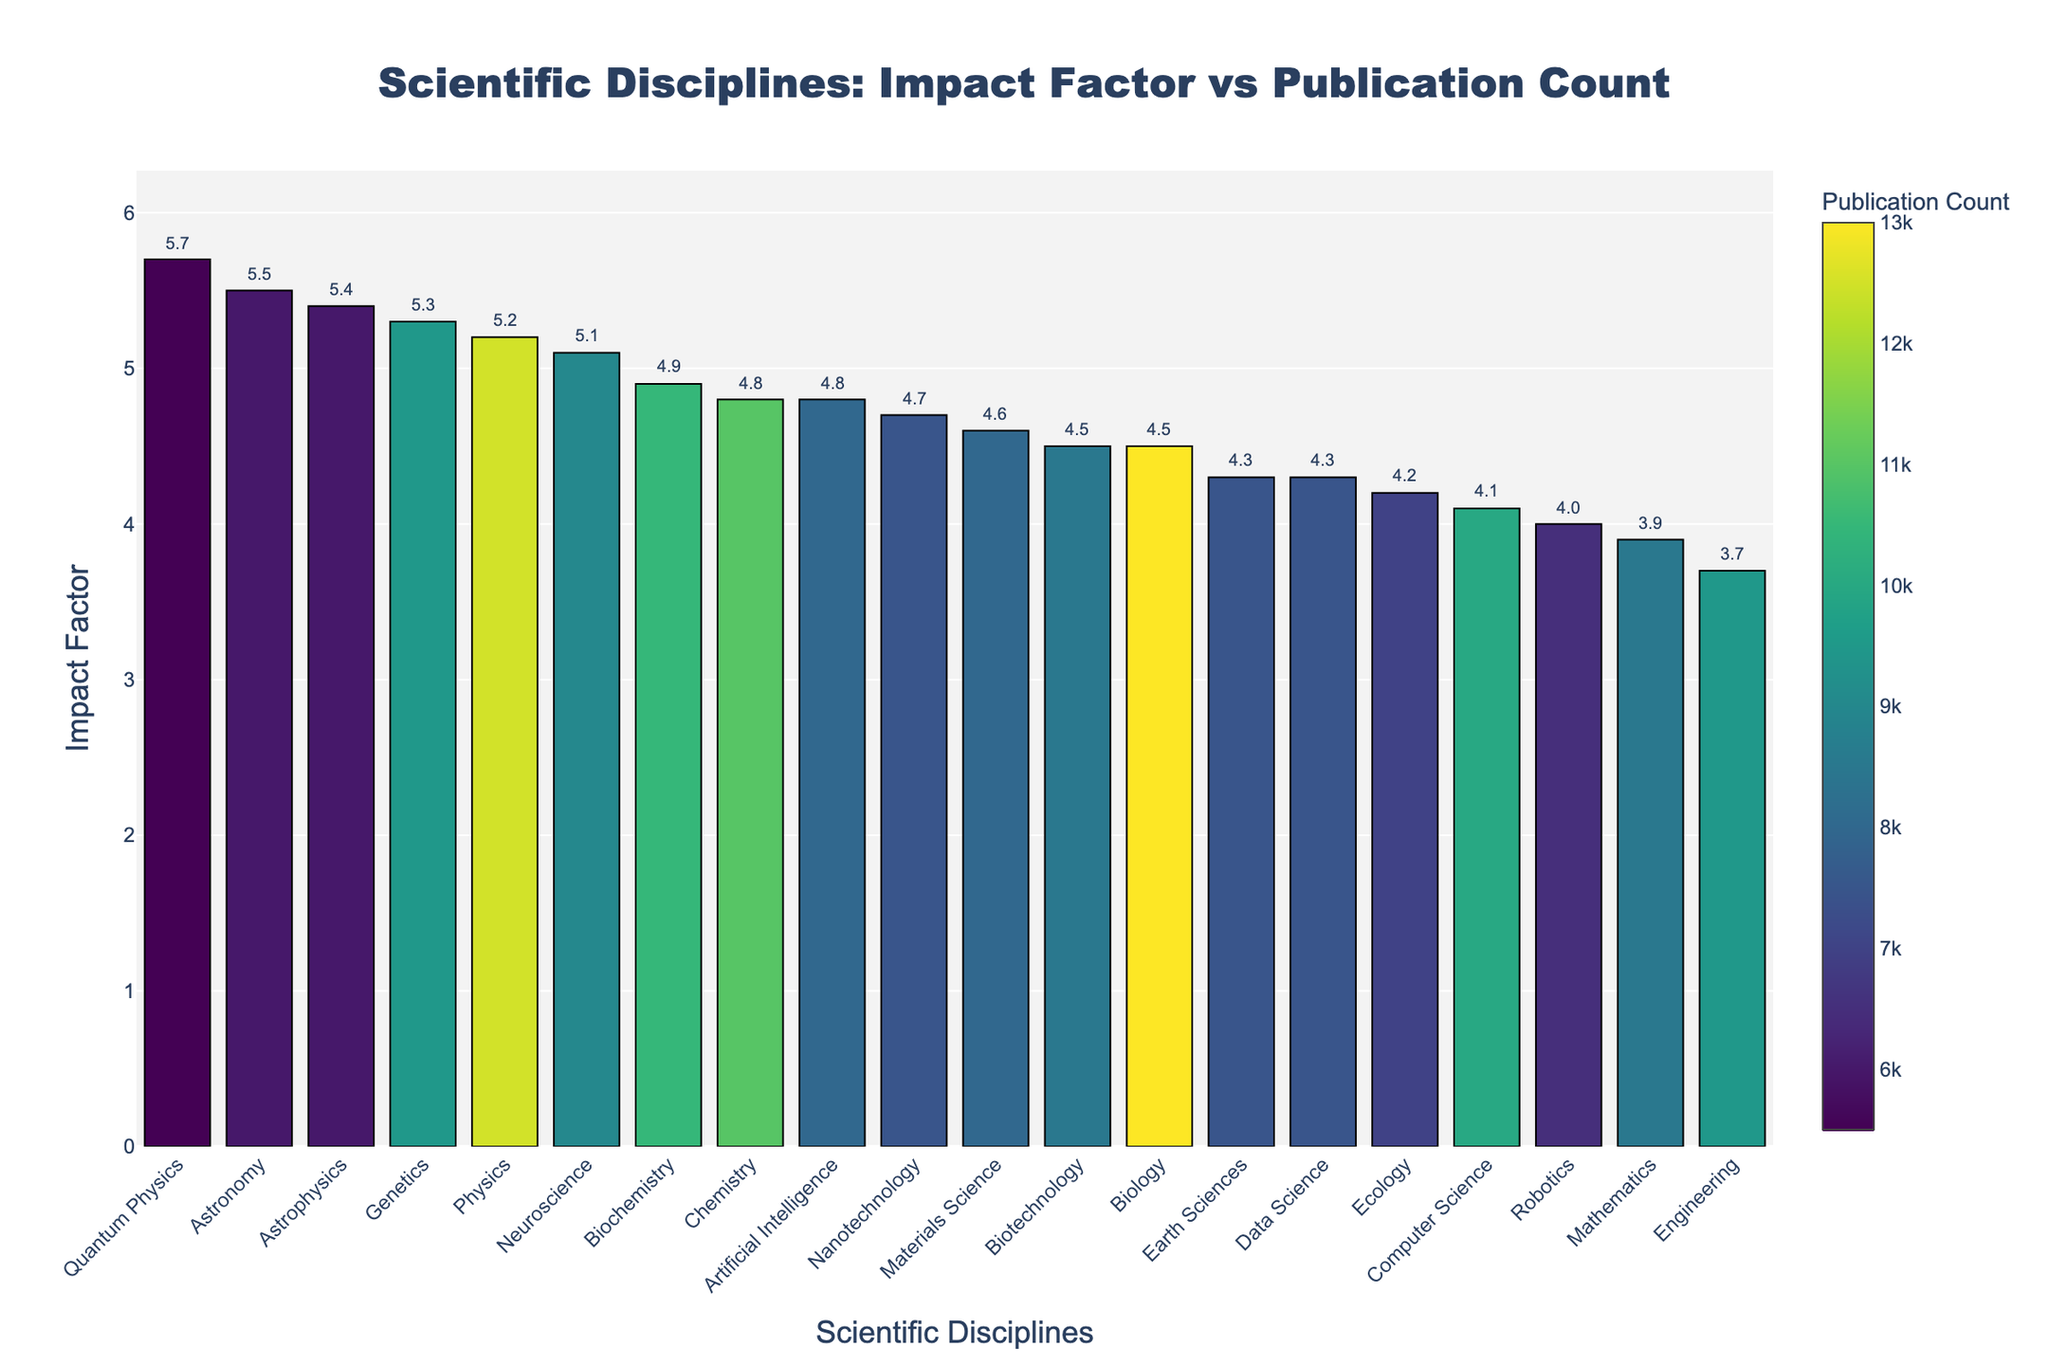What is the title of the figure? The title is found at the top of the figure, providing a clear summary of what the plot is about. It reads "Scientific Disciplines: Impact Factor vs Publication Count."
Answer: Scientific Disciplines: Impact Factor vs Publication Count Which scientific discipline has the highest impact factor? By scanning all the bars in the figure, the tallest bar represents the highest impact factor. This bar corresponds to Quantum Physics.
Answer: Quantum Physics How many scientific disciplines have an impact factor greater than 5? Count the number of bars that reach above the 5 mark on the y-axis. The disciplines are Physics, Astronomy, Neuroscience, Genetics, Astrophysics, and Quantum Physics.
Answer: 6 What is the publication count for the discipline with the highest impact factor? The discipline with the highest impact factor is Quantum Physics. Referring to the color scale, Quantum Physics has a publication count represented by its color, which is 5,500.
Answer: 5,500 Which discipline has the lowest impact factor? The shortest bar in the figure represents the lowest impact factor, which belongs to Engineering.
Answer: Engineering Compare the publication counts of Biology and Computer Science. Which one is higher? Locate the bars for Biology and Computer Science, then refer to the color scale. Biology's color intensity is higher than Computer Science, indicating a higher publication count.
Answer: Biology What is the difference in impact factor between Physics and Mathematics? Find the impact factors for both Physics (5.2) and Mathematics (3.9), then subtract Mathematics' impact factor from Physics'. \( 5.2 - 3.9 = 1.3 \)
Answer: 1.3 Which scientific discipline has the closest impact factor to Biotechnology? Find the impact factor of Biotechnology (4.5) and compare it to other disciplines. The closest impact factor is Biology with the same value of 4.5.
Answer: Biology How does the impact factor of Data Science compare to Earth Sciences? Locate the bars for Data Science and Earth Sciences and compare their heights. Both have similar impact factors around 4.3.
Answer: Equal 